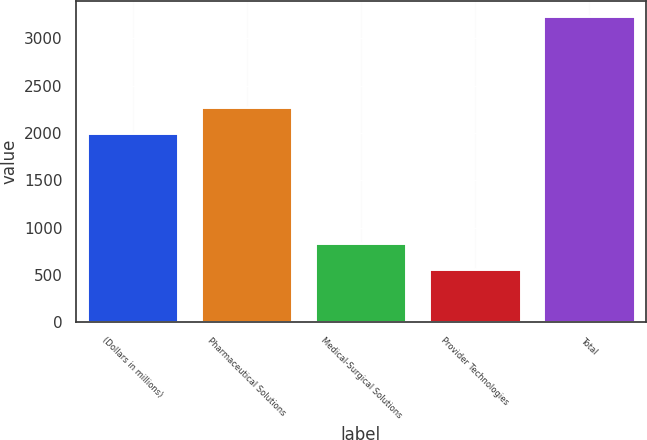<chart> <loc_0><loc_0><loc_500><loc_500><bar_chart><fcel>(Dollars in millions)<fcel>Pharmaceutical Solutions<fcel>Medical-Surgical Solutions<fcel>Provider Technologies<fcel>Total<nl><fcel>2004<fcel>2270.8<fcel>833.8<fcel>567<fcel>3235<nl></chart> 